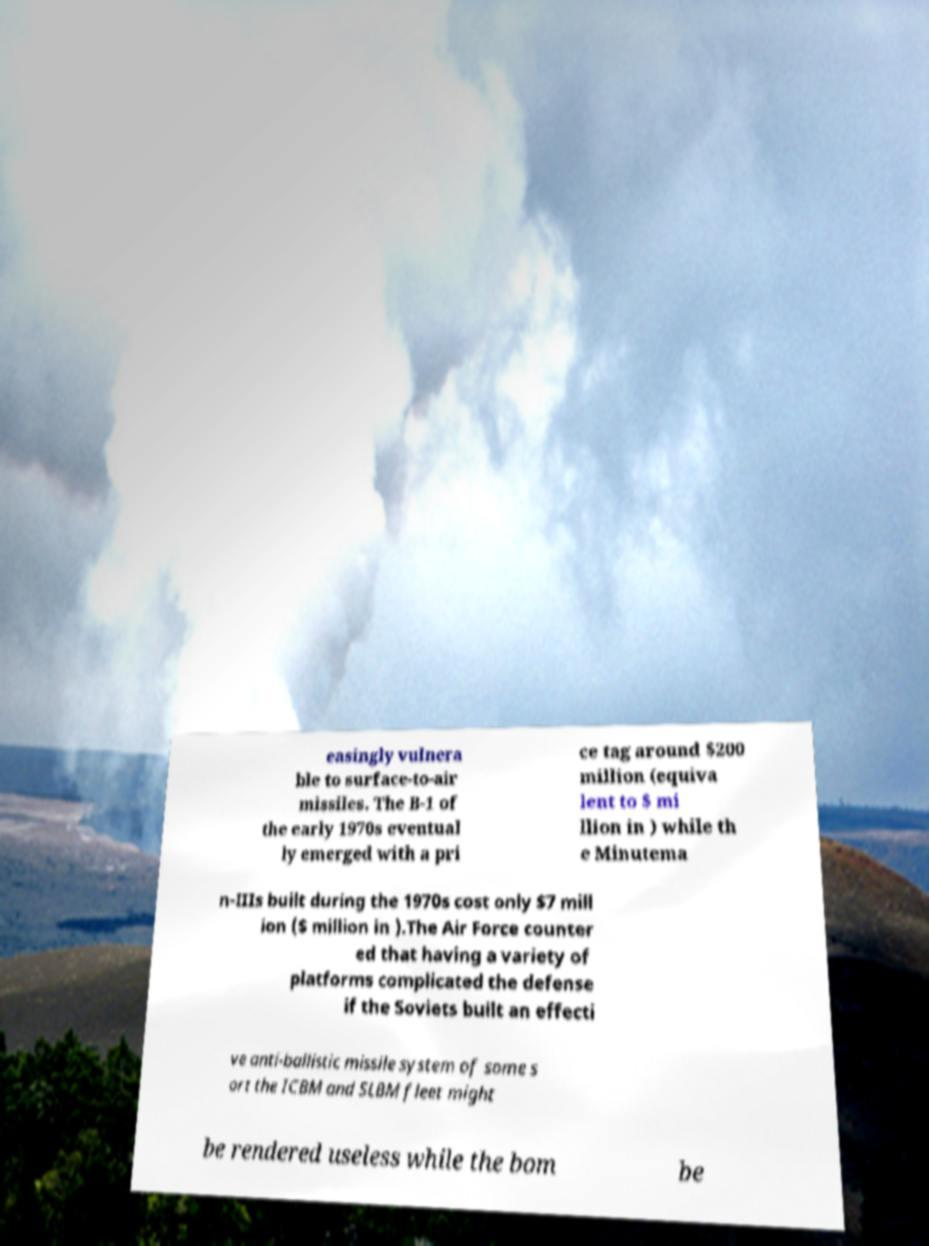Can you read and provide the text displayed in the image?This photo seems to have some interesting text. Can you extract and type it out for me? easingly vulnera ble to surface-to-air missiles. The B-1 of the early 1970s eventual ly emerged with a pri ce tag around $200 million (equiva lent to $ mi llion in ) while th e Minutema n-IIIs built during the 1970s cost only $7 mill ion ($ million in ).The Air Force counter ed that having a variety of platforms complicated the defense if the Soviets built an effecti ve anti-ballistic missile system of some s ort the ICBM and SLBM fleet might be rendered useless while the bom be 